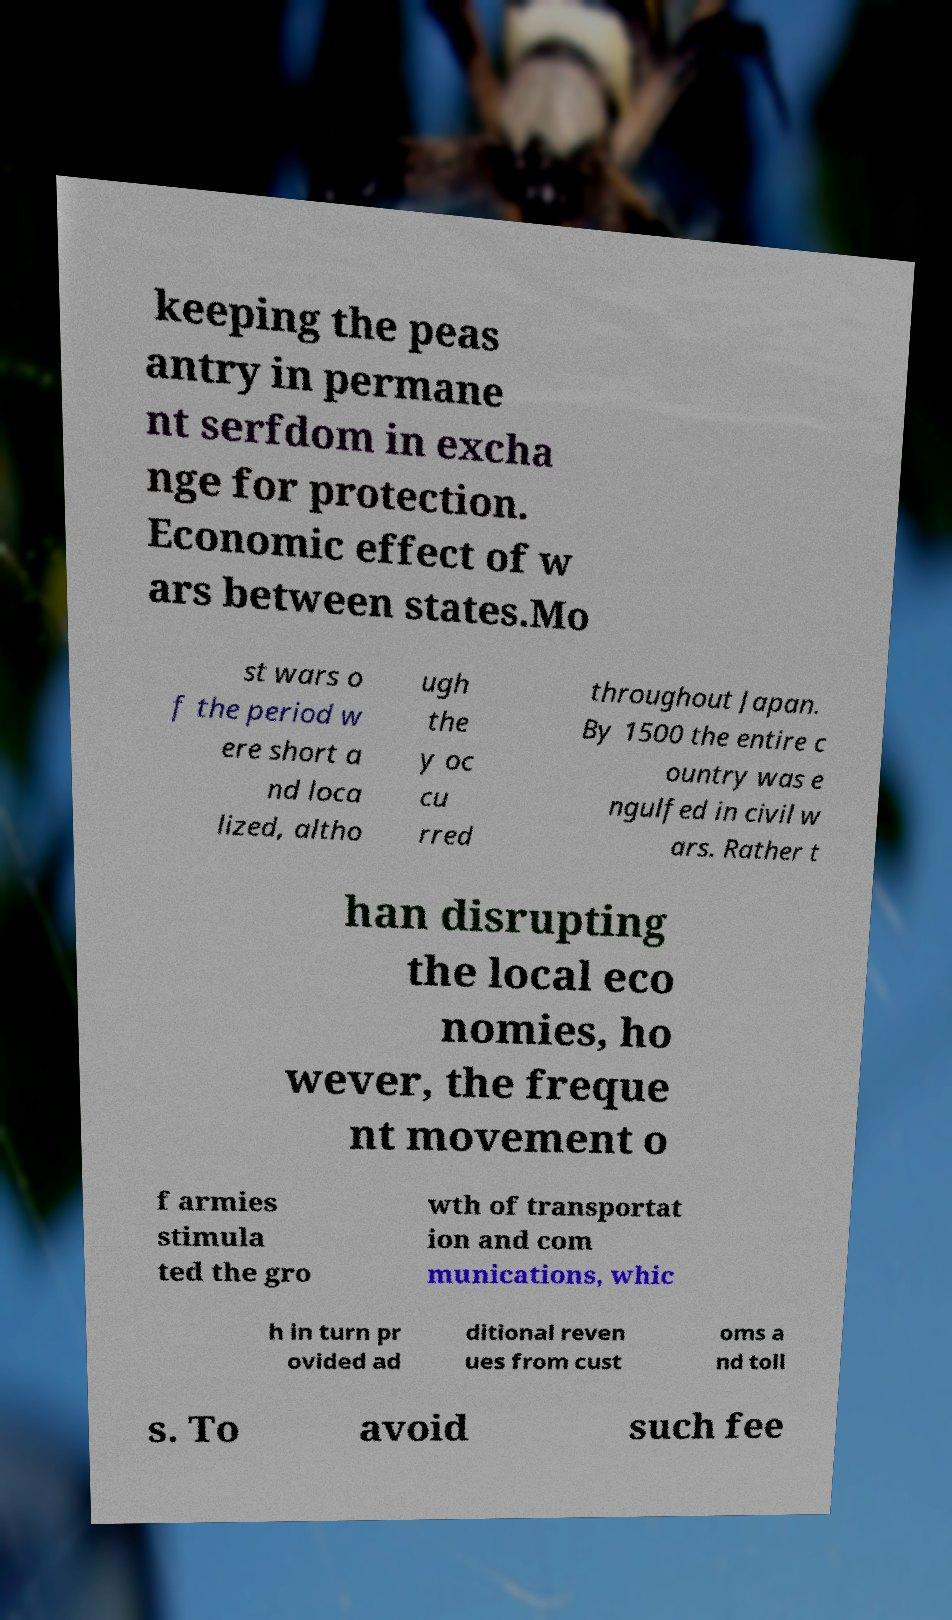Please identify and transcribe the text found in this image. keeping the peas antry in permane nt serfdom in excha nge for protection. Economic effect of w ars between states.Mo st wars o f the period w ere short a nd loca lized, altho ugh the y oc cu rred throughout Japan. By 1500 the entire c ountry was e ngulfed in civil w ars. Rather t han disrupting the local eco nomies, ho wever, the freque nt movement o f armies stimula ted the gro wth of transportat ion and com munications, whic h in turn pr ovided ad ditional reven ues from cust oms a nd toll s. To avoid such fee 